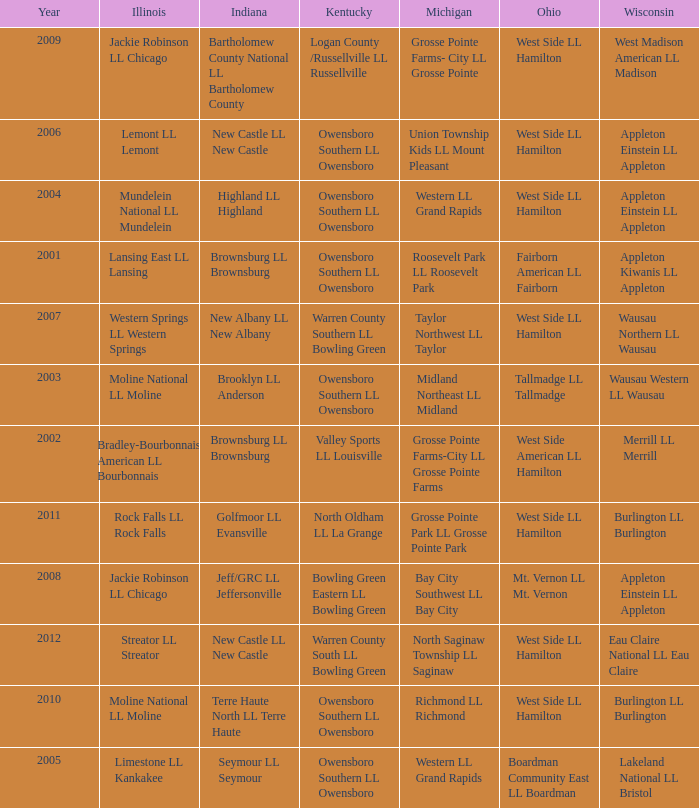What was the little league team from Indiana when the little league team from Michigan was Midland Northeast LL Midland? Brooklyn LL Anderson. Could you parse the entire table as a dict? {'header': ['Year', 'Illinois', 'Indiana', 'Kentucky', 'Michigan', 'Ohio', 'Wisconsin'], 'rows': [['2009', 'Jackie Robinson LL Chicago', 'Bartholomew County National LL Bartholomew County', 'Logan County /Russellville LL Russellville', 'Grosse Pointe Farms- City LL Grosse Pointe', 'West Side LL Hamilton', 'West Madison American LL Madison'], ['2006', 'Lemont LL Lemont', 'New Castle LL New Castle', 'Owensboro Southern LL Owensboro', 'Union Township Kids LL Mount Pleasant', 'West Side LL Hamilton', 'Appleton Einstein LL Appleton'], ['2004', 'Mundelein National LL Mundelein', 'Highland LL Highland', 'Owensboro Southern LL Owensboro', 'Western LL Grand Rapids', 'West Side LL Hamilton', 'Appleton Einstein LL Appleton'], ['2001', 'Lansing East LL Lansing', 'Brownsburg LL Brownsburg', 'Owensboro Southern LL Owensboro', 'Roosevelt Park LL Roosevelt Park', 'Fairborn American LL Fairborn', 'Appleton Kiwanis LL Appleton'], ['2007', 'Western Springs LL Western Springs', 'New Albany LL New Albany', 'Warren County Southern LL Bowling Green', 'Taylor Northwest LL Taylor', 'West Side LL Hamilton', 'Wausau Northern LL Wausau'], ['2003', 'Moline National LL Moline', 'Brooklyn LL Anderson', 'Owensboro Southern LL Owensboro', 'Midland Northeast LL Midland', 'Tallmadge LL Tallmadge', 'Wausau Western LL Wausau'], ['2002', 'Bradley-Bourbonnais American LL Bourbonnais', 'Brownsburg LL Brownsburg', 'Valley Sports LL Louisville', 'Grosse Pointe Farms-City LL Grosse Pointe Farms', 'West Side American LL Hamilton', 'Merrill LL Merrill'], ['2011', 'Rock Falls LL Rock Falls', 'Golfmoor LL Evansville', 'North Oldham LL La Grange', 'Grosse Pointe Park LL Grosse Pointe Park', 'West Side LL Hamilton', 'Burlington LL Burlington'], ['2008', 'Jackie Robinson LL Chicago', 'Jeff/GRC LL Jeffersonville', 'Bowling Green Eastern LL Bowling Green', 'Bay City Southwest LL Bay City', 'Mt. Vernon LL Mt. Vernon', 'Appleton Einstein LL Appleton'], ['2012', 'Streator LL Streator', 'New Castle LL New Castle', 'Warren County South LL Bowling Green', 'North Saginaw Township LL Saginaw', 'West Side LL Hamilton', 'Eau Claire National LL Eau Claire'], ['2010', 'Moline National LL Moline', 'Terre Haute North LL Terre Haute', 'Owensboro Southern LL Owensboro', 'Richmond LL Richmond', 'West Side LL Hamilton', 'Burlington LL Burlington'], ['2005', 'Limestone LL Kankakee', 'Seymour LL Seymour', 'Owensboro Southern LL Owensboro', 'Western LL Grand Rapids', 'Boardman Community East LL Boardman', 'Lakeland National LL Bristol']]} 